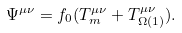<formula> <loc_0><loc_0><loc_500><loc_500>\Psi ^ { \mu \nu } = f _ { 0 } ( T _ { m } ^ { \mu \nu } + T _ { \Omega ( 1 ) } ^ { \mu \nu } ) .</formula> 